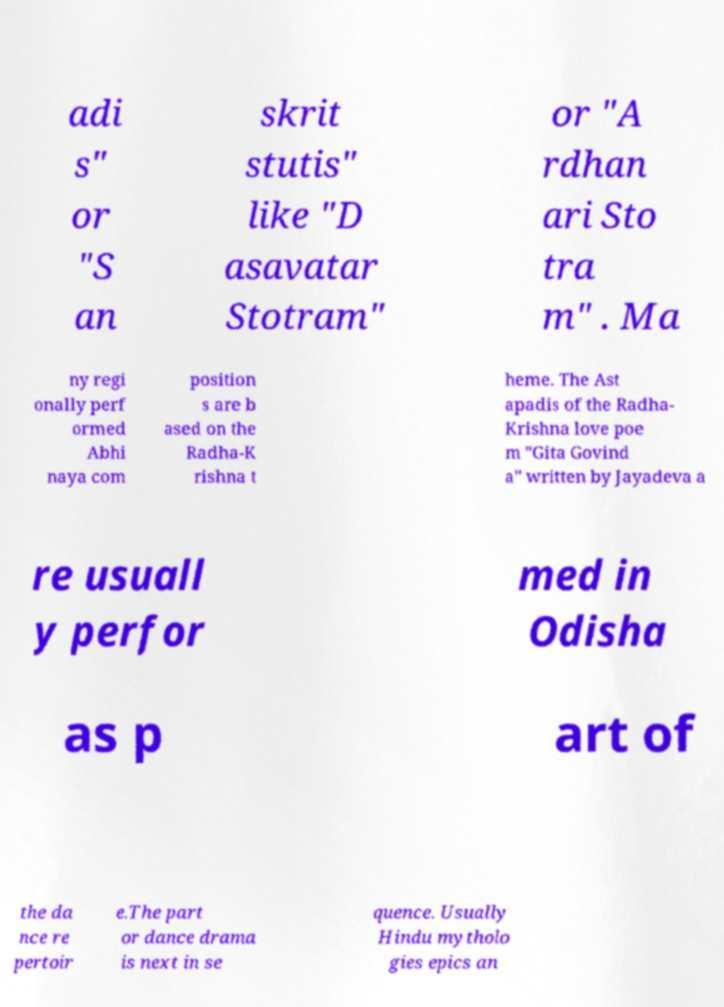Please identify and transcribe the text found in this image. adi s" or "S an skrit stutis" like "D asavatar Stotram" or "A rdhan ari Sto tra m" . Ma ny regi onally perf ormed Abhi naya com position s are b ased on the Radha-K rishna t heme. The Ast apadis of the Radha- Krishna love poe m "Gita Govind a" written by Jayadeva a re usuall y perfor med in Odisha as p art of the da nce re pertoir e.The part or dance drama is next in se quence. Usually Hindu mytholo gies epics an 